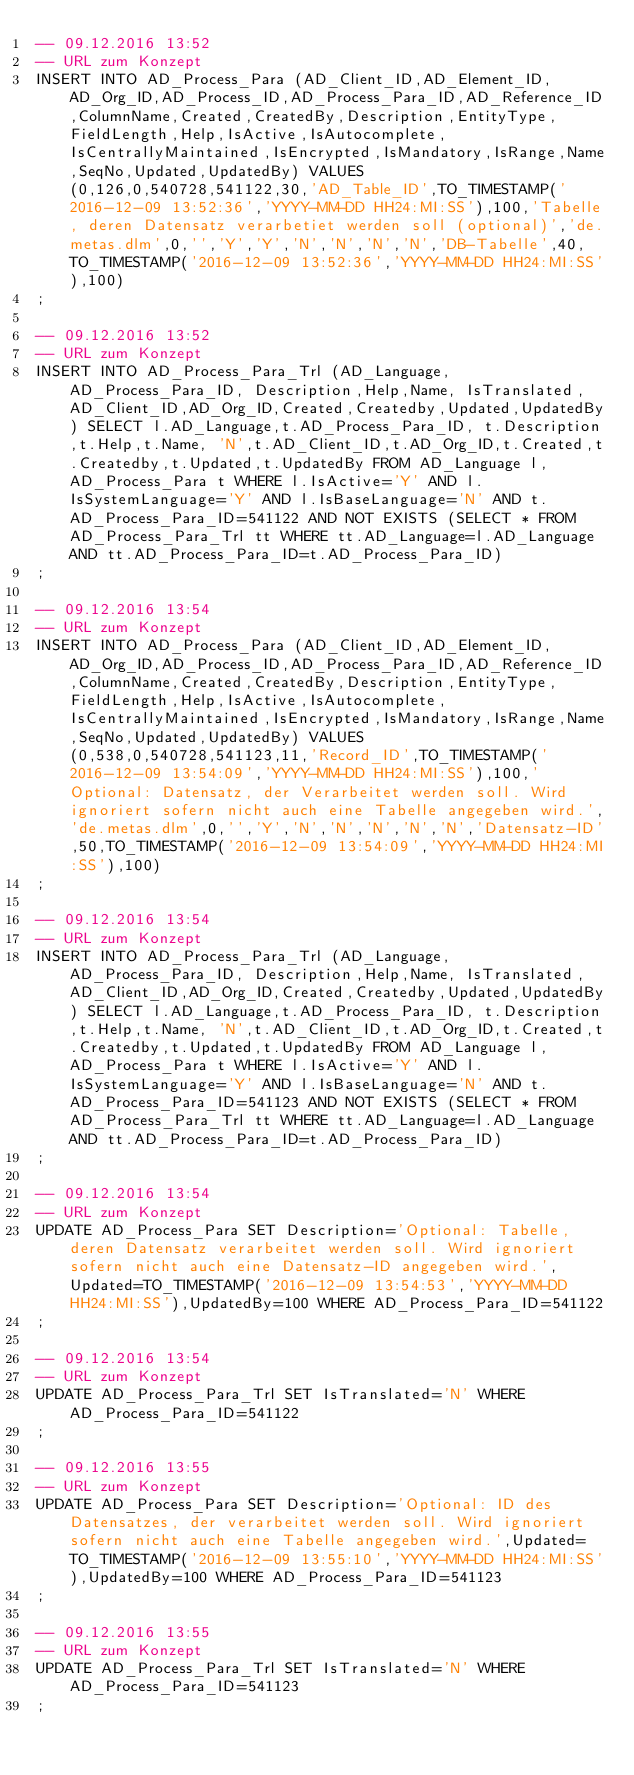Convert code to text. <code><loc_0><loc_0><loc_500><loc_500><_SQL_>-- 09.12.2016 13:52
-- URL zum Konzept
INSERT INTO AD_Process_Para (AD_Client_ID,AD_Element_ID,AD_Org_ID,AD_Process_ID,AD_Process_Para_ID,AD_Reference_ID,ColumnName,Created,CreatedBy,Description,EntityType,FieldLength,Help,IsActive,IsAutocomplete,IsCentrallyMaintained,IsEncrypted,IsMandatory,IsRange,Name,SeqNo,Updated,UpdatedBy) VALUES (0,126,0,540728,541122,30,'AD_Table_ID',TO_TIMESTAMP('2016-12-09 13:52:36','YYYY-MM-DD HH24:MI:SS'),100,'Tabelle, deren Datensatz verarbetiet werden soll (optional)','de.metas.dlm',0,'','Y','Y','N','N','N','N','DB-Tabelle',40,TO_TIMESTAMP('2016-12-09 13:52:36','YYYY-MM-DD HH24:MI:SS'),100)
;

-- 09.12.2016 13:52
-- URL zum Konzept
INSERT INTO AD_Process_Para_Trl (AD_Language,AD_Process_Para_ID, Description,Help,Name, IsTranslated,AD_Client_ID,AD_Org_ID,Created,Createdby,Updated,UpdatedBy) SELECT l.AD_Language,t.AD_Process_Para_ID, t.Description,t.Help,t.Name, 'N',t.AD_Client_ID,t.AD_Org_ID,t.Created,t.Createdby,t.Updated,t.UpdatedBy FROM AD_Language l, AD_Process_Para t WHERE l.IsActive='Y' AND l.IsSystemLanguage='Y' AND l.IsBaseLanguage='N' AND t.AD_Process_Para_ID=541122 AND NOT EXISTS (SELECT * FROM AD_Process_Para_Trl tt WHERE tt.AD_Language=l.AD_Language AND tt.AD_Process_Para_ID=t.AD_Process_Para_ID)
;

-- 09.12.2016 13:54
-- URL zum Konzept
INSERT INTO AD_Process_Para (AD_Client_ID,AD_Element_ID,AD_Org_ID,AD_Process_ID,AD_Process_Para_ID,AD_Reference_ID,ColumnName,Created,CreatedBy,Description,EntityType,FieldLength,Help,IsActive,IsAutocomplete,IsCentrallyMaintained,IsEncrypted,IsMandatory,IsRange,Name,SeqNo,Updated,UpdatedBy) VALUES (0,538,0,540728,541123,11,'Record_ID',TO_TIMESTAMP('2016-12-09 13:54:09','YYYY-MM-DD HH24:MI:SS'),100,'Optional: Datensatz, der Verarbeitet werden soll. Wird ignoriert sofern nicht auch eine Tabelle angegeben wird.','de.metas.dlm',0,'','Y','N','N','N','N','N','Datensatz-ID',50,TO_TIMESTAMP('2016-12-09 13:54:09','YYYY-MM-DD HH24:MI:SS'),100)
;

-- 09.12.2016 13:54
-- URL zum Konzept
INSERT INTO AD_Process_Para_Trl (AD_Language,AD_Process_Para_ID, Description,Help,Name, IsTranslated,AD_Client_ID,AD_Org_ID,Created,Createdby,Updated,UpdatedBy) SELECT l.AD_Language,t.AD_Process_Para_ID, t.Description,t.Help,t.Name, 'N',t.AD_Client_ID,t.AD_Org_ID,t.Created,t.Createdby,t.Updated,t.UpdatedBy FROM AD_Language l, AD_Process_Para t WHERE l.IsActive='Y' AND l.IsSystemLanguage='Y' AND l.IsBaseLanguage='N' AND t.AD_Process_Para_ID=541123 AND NOT EXISTS (SELECT * FROM AD_Process_Para_Trl tt WHERE tt.AD_Language=l.AD_Language AND tt.AD_Process_Para_ID=t.AD_Process_Para_ID)
;

-- 09.12.2016 13:54
-- URL zum Konzept
UPDATE AD_Process_Para SET Description='Optional: Tabelle, deren Datensatz verarbeitet werden soll. Wird ignoriert sofern nicht auch eine Datensatz-ID angegeben wird.',Updated=TO_TIMESTAMP('2016-12-09 13:54:53','YYYY-MM-DD HH24:MI:SS'),UpdatedBy=100 WHERE AD_Process_Para_ID=541122
;

-- 09.12.2016 13:54
-- URL zum Konzept
UPDATE AD_Process_Para_Trl SET IsTranslated='N' WHERE AD_Process_Para_ID=541122
;

-- 09.12.2016 13:55
-- URL zum Konzept
UPDATE AD_Process_Para SET Description='Optional: ID des Datensatzes, der verarbeitet werden soll. Wird ignoriert sofern nicht auch eine Tabelle angegeben wird.',Updated=TO_TIMESTAMP('2016-12-09 13:55:10','YYYY-MM-DD HH24:MI:SS'),UpdatedBy=100 WHERE AD_Process_Para_ID=541123
;

-- 09.12.2016 13:55
-- URL zum Konzept
UPDATE AD_Process_Para_Trl SET IsTranslated='N' WHERE AD_Process_Para_ID=541123
;

</code> 